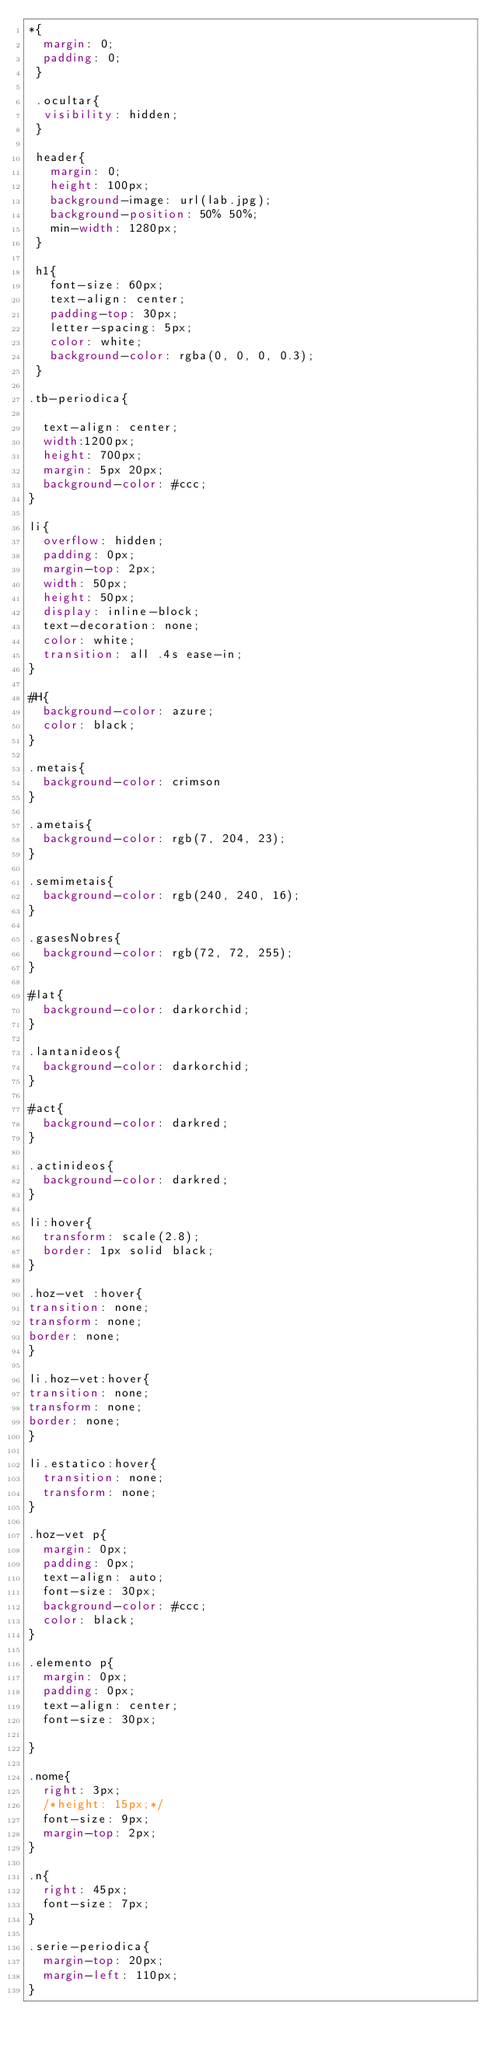Convert code to text. <code><loc_0><loc_0><loc_500><loc_500><_CSS_>*{
	margin: 0;
	padding: 0;
 }

 .ocultar{
 	visibility: hidden;
 }

 header{
	 margin: 0;
	 height: 100px;
	 background-image: url(lab.jpg);
	 background-position: 50% 50%;
	 min-width: 1280px;
 }

 h1{
	 font-size: 60px;
	 text-align: center;
	 padding-top: 30px;
	 letter-spacing: 5px;
	 color: white;
	 background-color: rgba(0, 0, 0, 0.3);
 }

.tb-periodica{
	
	text-align: center;
	width:1200px;
	height: 700px; 
	margin: 5px 20px;
	background-color: #ccc;
}

li{
	overflow: hidden;
	padding: 0px;
	margin-top: 2px;
	width: 50px;
	height: 50px;
	display: inline-block;
	text-decoration: none;
	color: white;
	transition: all .4s ease-in;
}

#H{
	background-color: azure;
	color: black;
}

.metais{
	background-color: crimson
}

.ametais{
	background-color: rgb(7, 204, 23);
}

.semimetais{
	background-color: rgb(240, 240, 16);
}

.gasesNobres{
	background-color: rgb(72, 72, 255);
}

#lat{
	background-color: darkorchid;
}

.lantanideos{
	background-color: darkorchid;
}

#act{
	background-color: darkred;
}

.actinideos{
	background-color: darkred;
}

li:hover{
	transform: scale(2.8);
	border: 1px solid black;	
}

.hoz-vet :hover{
transition: none;
transform: none;
border: none;
}

li.hoz-vet:hover{
transition: none;
transform: none;
border: none;
} 

li.estatico:hover{
	transition: none;
	transform: none;	
}

.hoz-vet p{
	margin: 0px;
	padding: 0px;
	text-align: auto;
	font-size: 30px;
	background-color: #ccc;
	color: black;	
}

.elemento p{
	margin: 0px;
	padding: 0px;
	text-align: center;
	font-size: 30px;
	
}

.nome{
	right: 3px;
	/*height: 15px;*/
	font-size: 9px;
	margin-top: 2px;
}

.n{
	right: 45px;
	font-size: 7px;
}

.serie-periodica{
	margin-top: 20px;
	margin-left: 110px;
}
</code> 